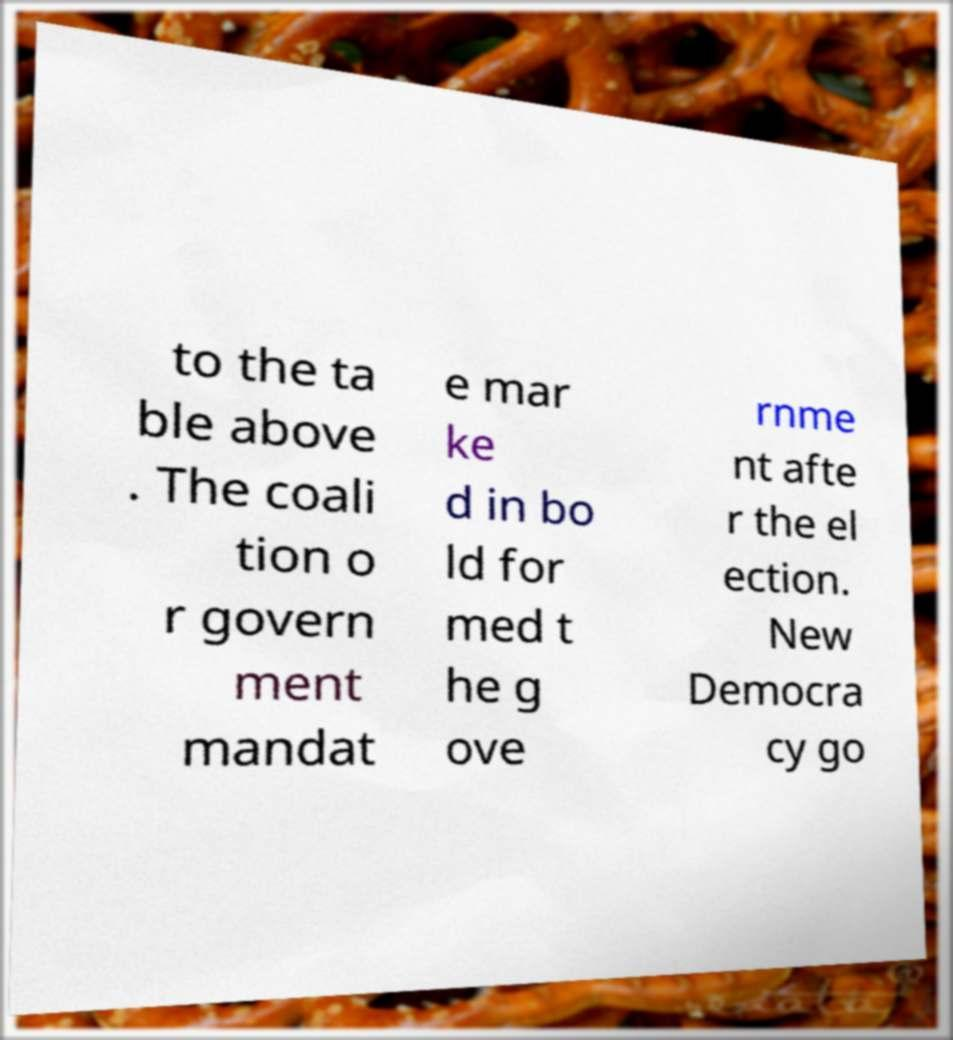Could you assist in decoding the text presented in this image and type it out clearly? to the ta ble above . The coali tion o r govern ment mandat e mar ke d in bo ld for med t he g ove rnme nt afte r the el ection. New Democra cy go 